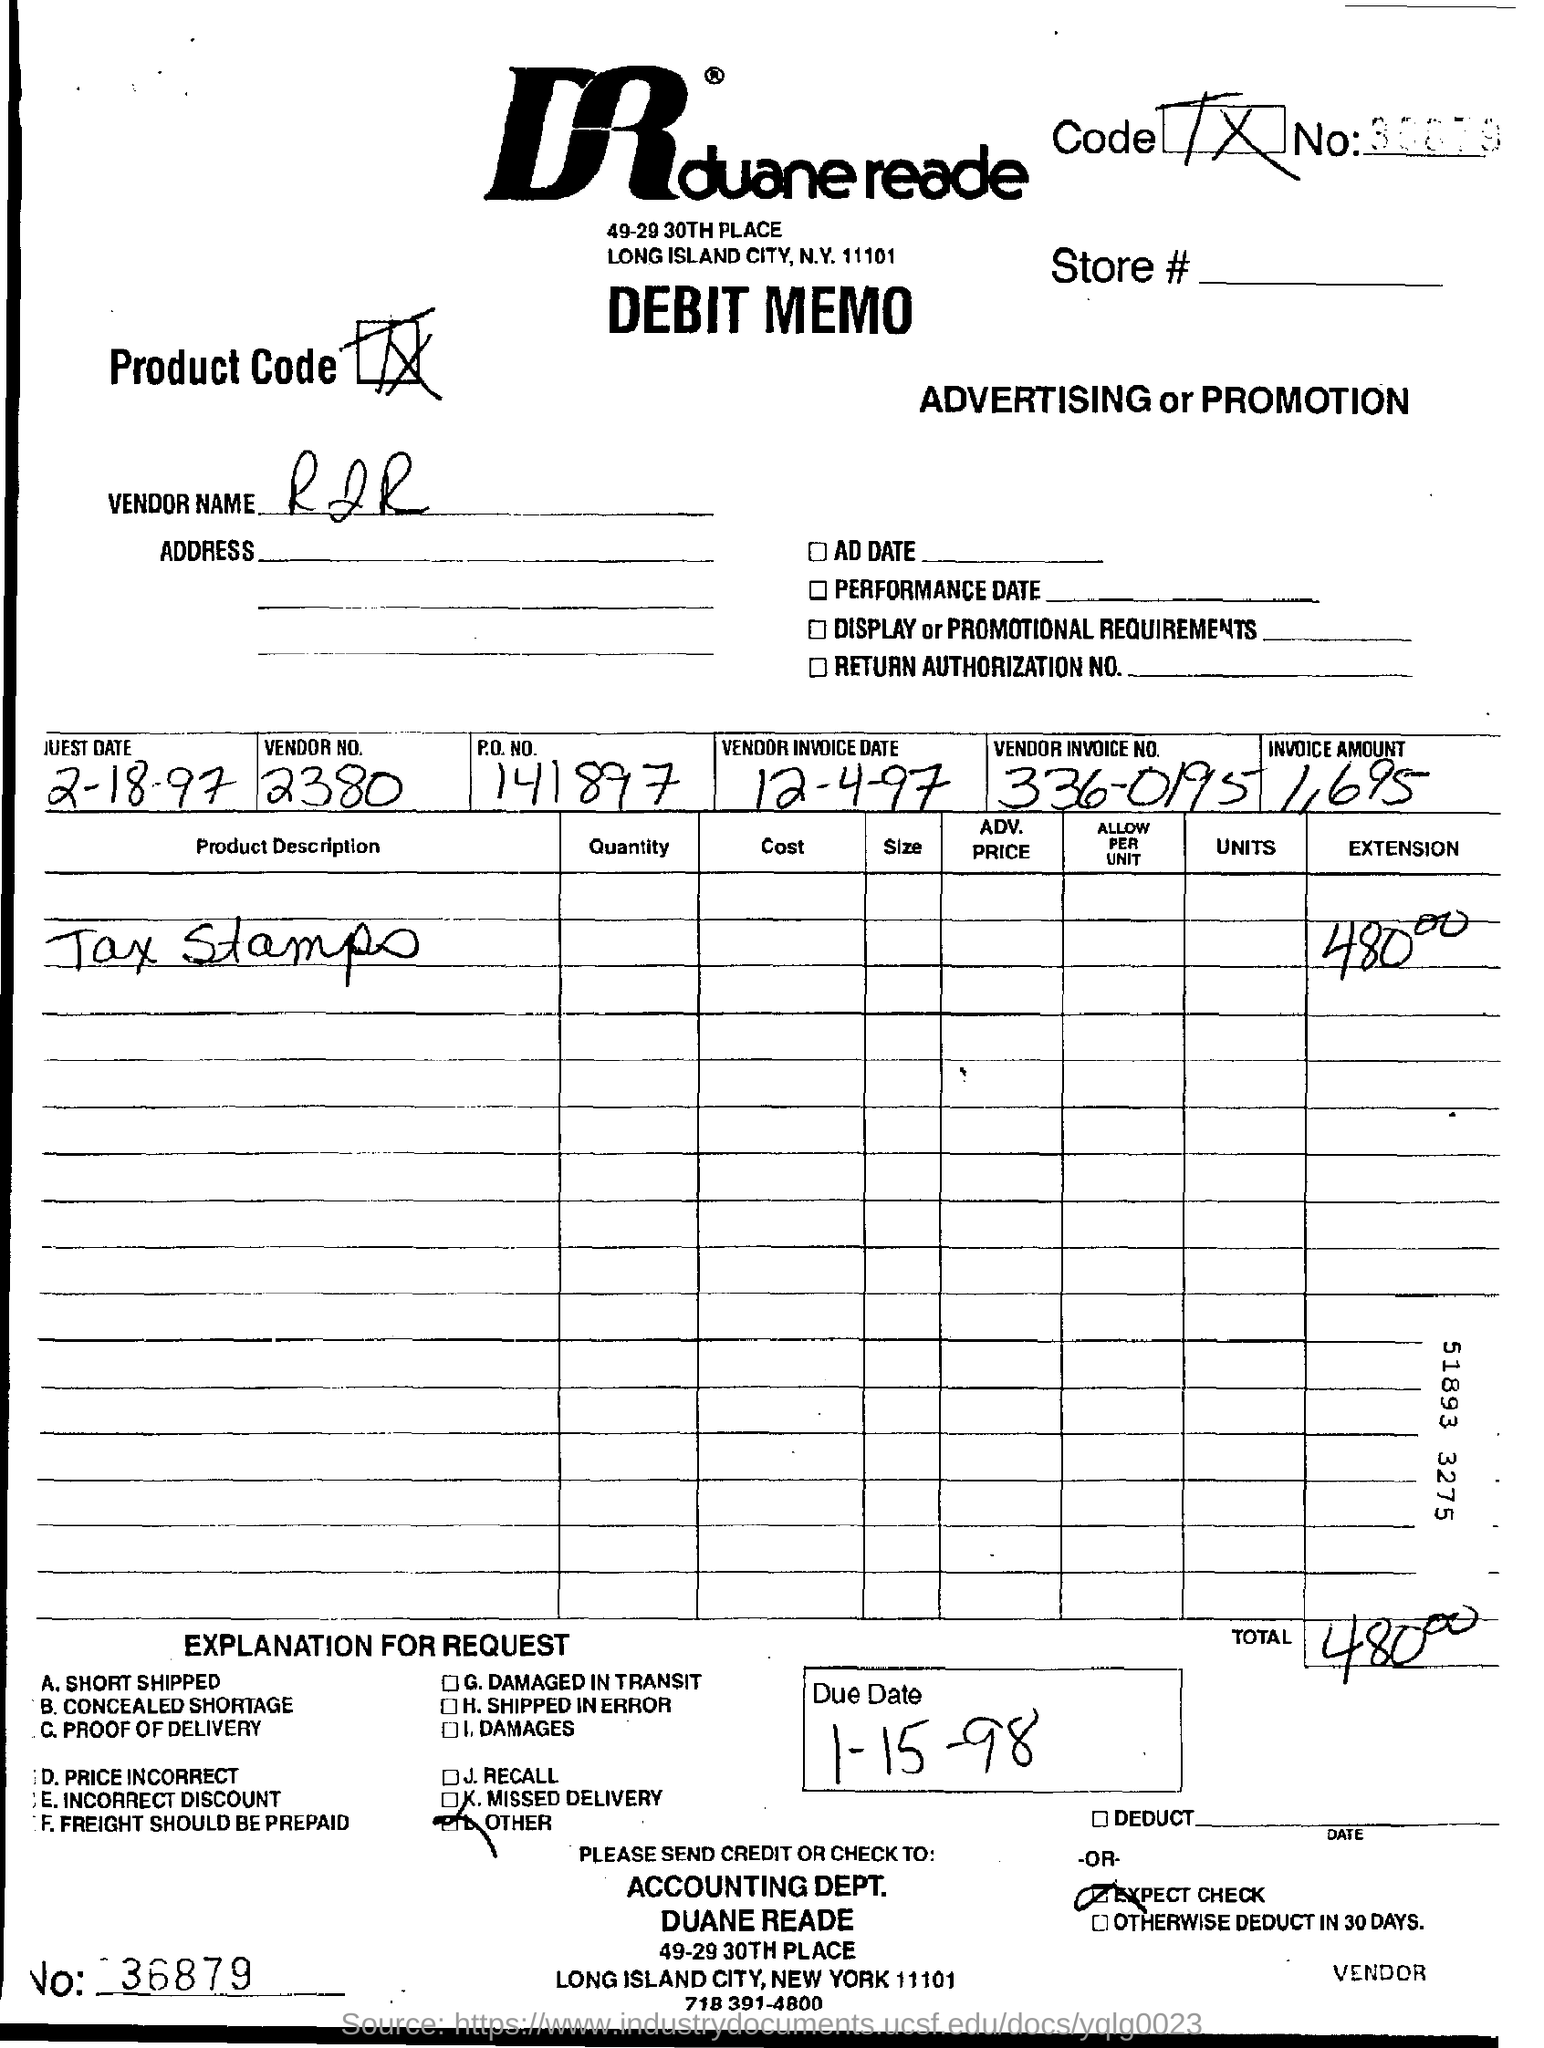What is mentioned in the product description ?
Make the answer very short. Tax stamps. What is the invoice  amount ?
Make the answer very short. 1,695. What is the vendor invoice no ?
Your answer should be very brief. 336-0195. What is the due date mentioned ?
Give a very brief answer. 1-15-98. What is the vendor no?
Offer a terse response. 2380. What is the p.o no
Keep it short and to the point. 141897. What is the vendor name ?
Your answer should be compact. RJR. 